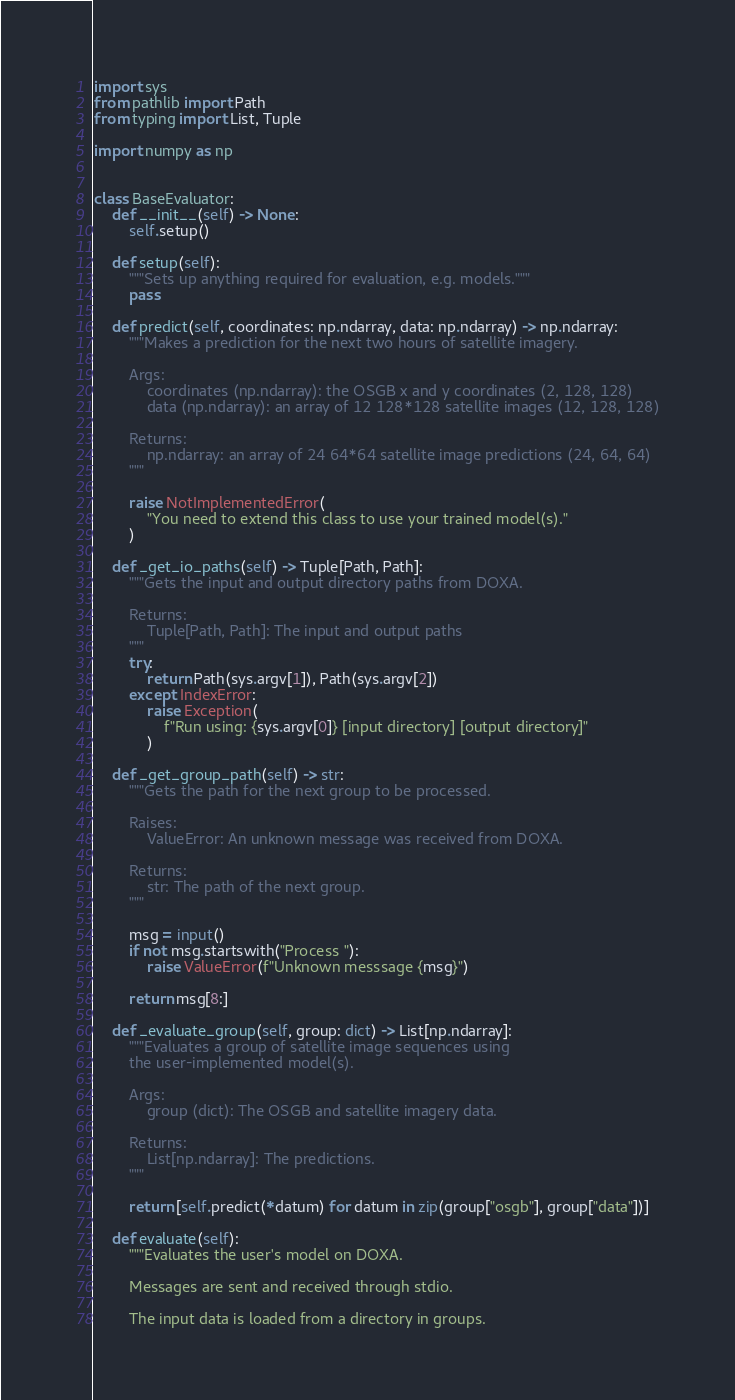Convert code to text. <code><loc_0><loc_0><loc_500><loc_500><_Python_>import sys
from pathlib import Path
from typing import List, Tuple

import numpy as np


class BaseEvaluator:
    def __init__(self) -> None:
        self.setup()

    def setup(self):
        """Sets up anything required for evaluation, e.g. models."""
        pass

    def predict(self, coordinates: np.ndarray, data: np.ndarray) -> np.ndarray:
        """Makes a prediction for the next two hours of satellite imagery.

        Args:
            coordinates (np.ndarray): the OSGB x and y coordinates (2, 128, 128)
            data (np.ndarray): an array of 12 128*128 satellite images (12, 128, 128)

        Returns:
            np.ndarray: an array of 24 64*64 satellite image predictions (24, 64, 64)
        """

        raise NotImplementedError(
            "You need to extend this class to use your trained model(s)."
        )

    def _get_io_paths(self) -> Tuple[Path, Path]:
        """Gets the input and output directory paths from DOXA.

        Returns:
            Tuple[Path, Path]: The input and output paths
        """
        try:
            return Path(sys.argv[1]), Path(sys.argv[2])
        except IndexError:
            raise Exception(
                f"Run using: {sys.argv[0]} [input directory] [output directory]"
            )

    def _get_group_path(self) -> str:
        """Gets the path for the next group to be processed.

        Raises:
            ValueError: An unknown message was received from DOXA.

        Returns:
            str: The path of the next group.
        """

        msg = input()
        if not msg.startswith("Process "):
            raise ValueError(f"Unknown messsage {msg}")

        return msg[8:]

    def _evaluate_group(self, group: dict) -> List[np.ndarray]:
        """Evaluates a group of satellite image sequences using
        the user-implemented model(s).

        Args:
            group (dict): The OSGB and satellite imagery data.

        Returns:
            List[np.ndarray]: The predictions.
        """

        return [self.predict(*datum) for datum in zip(group["osgb"], group["data"])]

    def evaluate(self):
        """Evaluates the user's model on DOXA.

        Messages are sent and received through stdio.

        The input data is loaded from a directory in groups.
</code> 